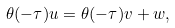Convert formula to latex. <formula><loc_0><loc_0><loc_500><loc_500>\theta ( - \tau ) u = \theta ( - \tau ) v + w ,</formula> 